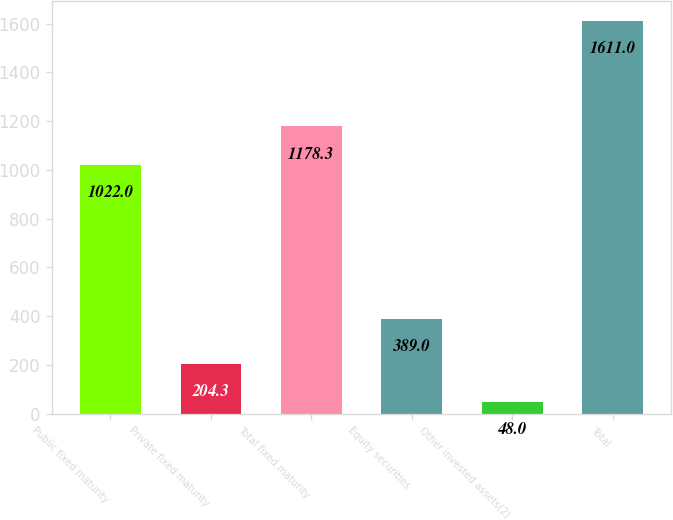Convert chart to OTSL. <chart><loc_0><loc_0><loc_500><loc_500><bar_chart><fcel>Public fixed maturity<fcel>Private fixed maturity<fcel>Total fixed maturity<fcel>Equity securities<fcel>Other invested assets(2)<fcel>Total<nl><fcel>1022<fcel>204.3<fcel>1178.3<fcel>389<fcel>48<fcel>1611<nl></chart> 